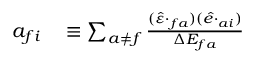Convert formula to latex. <formula><loc_0><loc_0><loc_500><loc_500>\begin{array} { r l } { a _ { f i } } & \equiv \sum _ { a \neq f } \frac { ( \ v { \hat { \varepsilon } } \cdot { \ v { D } } _ { f a } ) ( \ v { \hat { e } } \cdot { \ v { D } } _ { a i } ) } { \Delta { E _ { f a } } } } \end{array}</formula> 